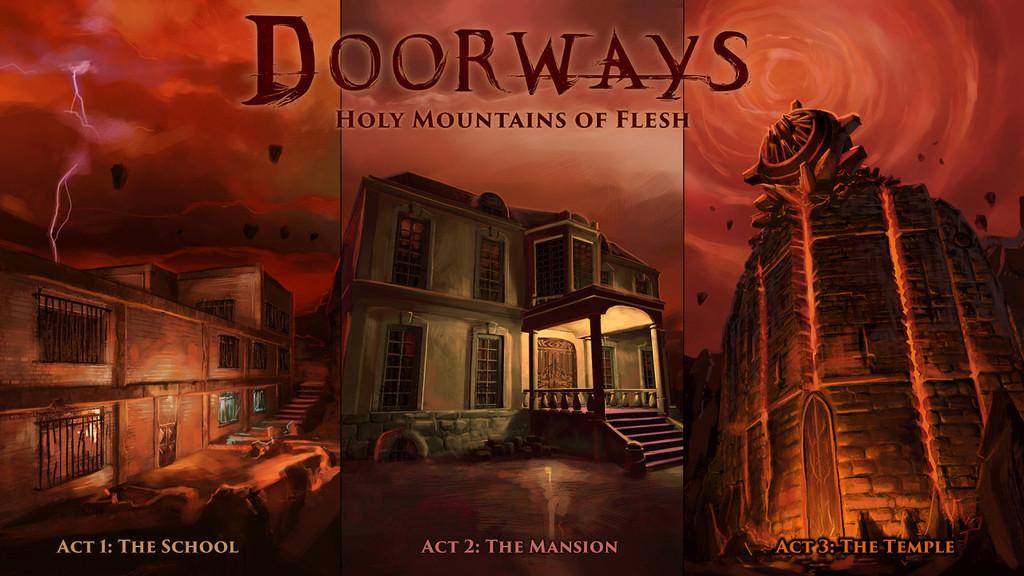What is act 1?
Give a very brief answer. The school. 